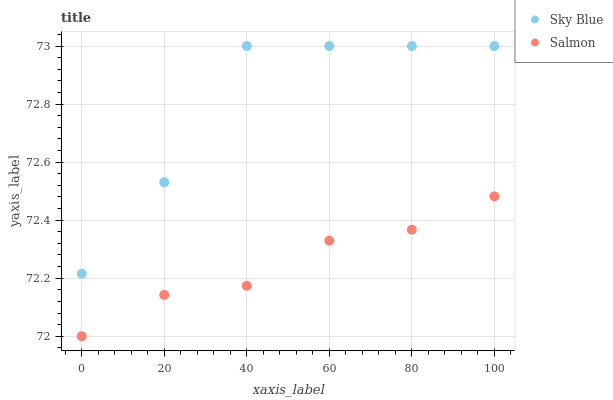Does Salmon have the minimum area under the curve?
Answer yes or no. Yes. Does Sky Blue have the maximum area under the curve?
Answer yes or no. Yes. Does Salmon have the maximum area under the curve?
Answer yes or no. No. Is Salmon the smoothest?
Answer yes or no. Yes. Is Sky Blue the roughest?
Answer yes or no. Yes. Is Salmon the roughest?
Answer yes or no. No. Does Salmon have the lowest value?
Answer yes or no. Yes. Does Sky Blue have the highest value?
Answer yes or no. Yes. Does Salmon have the highest value?
Answer yes or no. No. Is Salmon less than Sky Blue?
Answer yes or no. Yes. Is Sky Blue greater than Salmon?
Answer yes or no. Yes. Does Salmon intersect Sky Blue?
Answer yes or no. No. 